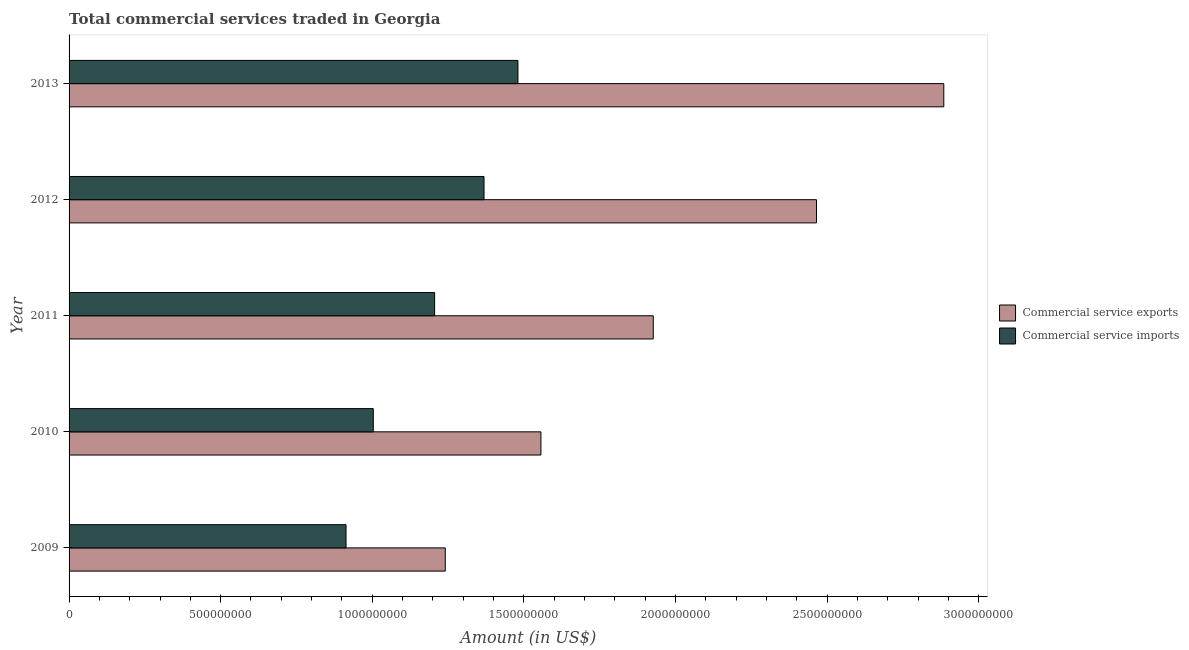How many different coloured bars are there?
Provide a short and direct response. 2. How many groups of bars are there?
Your response must be concise. 5. Are the number of bars on each tick of the Y-axis equal?
Provide a short and direct response. Yes. How many bars are there on the 1st tick from the top?
Keep it short and to the point. 2. What is the label of the 5th group of bars from the top?
Offer a very short reply. 2009. What is the amount of commercial service imports in 2011?
Provide a succinct answer. 1.21e+09. Across all years, what is the maximum amount of commercial service imports?
Keep it short and to the point. 1.48e+09. Across all years, what is the minimum amount of commercial service exports?
Your response must be concise. 1.24e+09. In which year was the amount of commercial service imports maximum?
Keep it short and to the point. 2013. What is the total amount of commercial service imports in the graph?
Your answer should be compact. 5.97e+09. What is the difference between the amount of commercial service imports in 2010 and that in 2012?
Keep it short and to the point. -3.65e+08. What is the difference between the amount of commercial service imports in 2010 and the amount of commercial service exports in 2011?
Offer a terse response. -9.23e+08. What is the average amount of commercial service imports per year?
Make the answer very short. 1.19e+09. In the year 2010, what is the difference between the amount of commercial service imports and amount of commercial service exports?
Give a very brief answer. -5.53e+08. In how many years, is the amount of commercial service exports greater than 1500000000 US$?
Give a very brief answer. 4. What is the ratio of the amount of commercial service exports in 2012 to that in 2013?
Provide a succinct answer. 0.85. Is the amount of commercial service exports in 2009 less than that in 2010?
Provide a succinct answer. Yes. Is the difference between the amount of commercial service exports in 2009 and 2010 greater than the difference between the amount of commercial service imports in 2009 and 2010?
Provide a succinct answer. No. What is the difference between the highest and the second highest amount of commercial service imports?
Make the answer very short. 1.12e+08. What is the difference between the highest and the lowest amount of commercial service exports?
Your answer should be very brief. 1.64e+09. Is the sum of the amount of commercial service imports in 2011 and 2012 greater than the maximum amount of commercial service exports across all years?
Provide a succinct answer. No. What does the 2nd bar from the top in 2009 represents?
Make the answer very short. Commercial service exports. What does the 1st bar from the bottom in 2012 represents?
Provide a succinct answer. Commercial service exports. Are the values on the major ticks of X-axis written in scientific E-notation?
Provide a succinct answer. No. Does the graph contain any zero values?
Give a very brief answer. No. Does the graph contain grids?
Provide a succinct answer. No. Where does the legend appear in the graph?
Your answer should be very brief. Center right. How are the legend labels stacked?
Your response must be concise. Vertical. What is the title of the graph?
Offer a terse response. Total commercial services traded in Georgia. Does "Current US$" appear as one of the legend labels in the graph?
Offer a terse response. No. What is the label or title of the X-axis?
Ensure brevity in your answer.  Amount (in US$). What is the label or title of the Y-axis?
Offer a terse response. Year. What is the Amount (in US$) in Commercial service exports in 2009?
Provide a succinct answer. 1.24e+09. What is the Amount (in US$) in Commercial service imports in 2009?
Give a very brief answer. 9.13e+08. What is the Amount (in US$) of Commercial service exports in 2010?
Your answer should be very brief. 1.56e+09. What is the Amount (in US$) of Commercial service imports in 2010?
Give a very brief answer. 1.00e+09. What is the Amount (in US$) of Commercial service exports in 2011?
Your response must be concise. 1.93e+09. What is the Amount (in US$) in Commercial service imports in 2011?
Make the answer very short. 1.21e+09. What is the Amount (in US$) in Commercial service exports in 2012?
Offer a very short reply. 2.47e+09. What is the Amount (in US$) of Commercial service imports in 2012?
Provide a short and direct response. 1.37e+09. What is the Amount (in US$) of Commercial service exports in 2013?
Give a very brief answer. 2.89e+09. What is the Amount (in US$) in Commercial service imports in 2013?
Your answer should be compact. 1.48e+09. Across all years, what is the maximum Amount (in US$) in Commercial service exports?
Keep it short and to the point. 2.89e+09. Across all years, what is the maximum Amount (in US$) in Commercial service imports?
Provide a succinct answer. 1.48e+09. Across all years, what is the minimum Amount (in US$) in Commercial service exports?
Make the answer very short. 1.24e+09. Across all years, what is the minimum Amount (in US$) of Commercial service imports?
Your answer should be compact. 9.13e+08. What is the total Amount (in US$) in Commercial service exports in the graph?
Give a very brief answer. 1.01e+1. What is the total Amount (in US$) of Commercial service imports in the graph?
Provide a short and direct response. 5.97e+09. What is the difference between the Amount (in US$) of Commercial service exports in 2009 and that in 2010?
Your response must be concise. -3.15e+08. What is the difference between the Amount (in US$) of Commercial service imports in 2009 and that in 2010?
Ensure brevity in your answer.  -8.99e+07. What is the difference between the Amount (in US$) of Commercial service exports in 2009 and that in 2011?
Your answer should be very brief. -6.86e+08. What is the difference between the Amount (in US$) of Commercial service imports in 2009 and that in 2011?
Offer a very short reply. -2.92e+08. What is the difference between the Amount (in US$) of Commercial service exports in 2009 and that in 2012?
Your response must be concise. -1.22e+09. What is the difference between the Amount (in US$) of Commercial service imports in 2009 and that in 2012?
Make the answer very short. -4.55e+08. What is the difference between the Amount (in US$) of Commercial service exports in 2009 and that in 2013?
Give a very brief answer. -1.64e+09. What is the difference between the Amount (in US$) in Commercial service imports in 2009 and that in 2013?
Provide a succinct answer. -5.67e+08. What is the difference between the Amount (in US$) in Commercial service exports in 2010 and that in 2011?
Provide a succinct answer. -3.71e+08. What is the difference between the Amount (in US$) of Commercial service imports in 2010 and that in 2011?
Provide a succinct answer. -2.02e+08. What is the difference between the Amount (in US$) of Commercial service exports in 2010 and that in 2012?
Offer a very short reply. -9.09e+08. What is the difference between the Amount (in US$) of Commercial service imports in 2010 and that in 2012?
Provide a succinct answer. -3.65e+08. What is the difference between the Amount (in US$) of Commercial service exports in 2010 and that in 2013?
Offer a very short reply. -1.33e+09. What is the difference between the Amount (in US$) of Commercial service imports in 2010 and that in 2013?
Offer a very short reply. -4.77e+08. What is the difference between the Amount (in US$) in Commercial service exports in 2011 and that in 2012?
Make the answer very short. -5.38e+08. What is the difference between the Amount (in US$) of Commercial service imports in 2011 and that in 2012?
Make the answer very short. -1.63e+08. What is the difference between the Amount (in US$) in Commercial service exports in 2011 and that in 2013?
Ensure brevity in your answer.  -9.58e+08. What is the difference between the Amount (in US$) in Commercial service imports in 2011 and that in 2013?
Keep it short and to the point. -2.75e+08. What is the difference between the Amount (in US$) in Commercial service exports in 2012 and that in 2013?
Offer a very short reply. -4.20e+08. What is the difference between the Amount (in US$) of Commercial service imports in 2012 and that in 2013?
Your response must be concise. -1.12e+08. What is the difference between the Amount (in US$) of Commercial service exports in 2009 and the Amount (in US$) of Commercial service imports in 2010?
Provide a short and direct response. 2.37e+08. What is the difference between the Amount (in US$) of Commercial service exports in 2009 and the Amount (in US$) of Commercial service imports in 2011?
Keep it short and to the point. 3.51e+07. What is the difference between the Amount (in US$) in Commercial service exports in 2009 and the Amount (in US$) in Commercial service imports in 2012?
Your response must be concise. -1.28e+08. What is the difference between the Amount (in US$) of Commercial service exports in 2009 and the Amount (in US$) of Commercial service imports in 2013?
Your answer should be compact. -2.40e+08. What is the difference between the Amount (in US$) in Commercial service exports in 2010 and the Amount (in US$) in Commercial service imports in 2011?
Provide a short and direct response. 3.51e+08. What is the difference between the Amount (in US$) in Commercial service exports in 2010 and the Amount (in US$) in Commercial service imports in 2012?
Offer a terse response. 1.88e+08. What is the difference between the Amount (in US$) in Commercial service exports in 2010 and the Amount (in US$) in Commercial service imports in 2013?
Your response must be concise. 7.58e+07. What is the difference between the Amount (in US$) of Commercial service exports in 2011 and the Amount (in US$) of Commercial service imports in 2012?
Provide a short and direct response. 5.58e+08. What is the difference between the Amount (in US$) in Commercial service exports in 2011 and the Amount (in US$) in Commercial service imports in 2013?
Provide a succinct answer. 4.46e+08. What is the difference between the Amount (in US$) of Commercial service exports in 2012 and the Amount (in US$) of Commercial service imports in 2013?
Give a very brief answer. 9.85e+08. What is the average Amount (in US$) in Commercial service exports per year?
Provide a short and direct response. 2.01e+09. What is the average Amount (in US$) of Commercial service imports per year?
Your answer should be compact. 1.19e+09. In the year 2009, what is the difference between the Amount (in US$) of Commercial service exports and Amount (in US$) of Commercial service imports?
Offer a very short reply. 3.27e+08. In the year 2010, what is the difference between the Amount (in US$) in Commercial service exports and Amount (in US$) in Commercial service imports?
Your answer should be compact. 5.53e+08. In the year 2011, what is the difference between the Amount (in US$) in Commercial service exports and Amount (in US$) in Commercial service imports?
Offer a terse response. 7.21e+08. In the year 2012, what is the difference between the Amount (in US$) in Commercial service exports and Amount (in US$) in Commercial service imports?
Your answer should be compact. 1.10e+09. In the year 2013, what is the difference between the Amount (in US$) of Commercial service exports and Amount (in US$) of Commercial service imports?
Make the answer very short. 1.40e+09. What is the ratio of the Amount (in US$) in Commercial service exports in 2009 to that in 2010?
Keep it short and to the point. 0.8. What is the ratio of the Amount (in US$) in Commercial service imports in 2009 to that in 2010?
Your answer should be compact. 0.91. What is the ratio of the Amount (in US$) in Commercial service exports in 2009 to that in 2011?
Your answer should be compact. 0.64. What is the ratio of the Amount (in US$) in Commercial service imports in 2009 to that in 2011?
Provide a succinct answer. 0.76. What is the ratio of the Amount (in US$) in Commercial service exports in 2009 to that in 2012?
Give a very brief answer. 0.5. What is the ratio of the Amount (in US$) of Commercial service imports in 2009 to that in 2012?
Offer a very short reply. 0.67. What is the ratio of the Amount (in US$) of Commercial service exports in 2009 to that in 2013?
Keep it short and to the point. 0.43. What is the ratio of the Amount (in US$) of Commercial service imports in 2009 to that in 2013?
Provide a short and direct response. 0.62. What is the ratio of the Amount (in US$) in Commercial service exports in 2010 to that in 2011?
Your answer should be very brief. 0.81. What is the ratio of the Amount (in US$) in Commercial service imports in 2010 to that in 2011?
Offer a very short reply. 0.83. What is the ratio of the Amount (in US$) of Commercial service exports in 2010 to that in 2012?
Your answer should be very brief. 0.63. What is the ratio of the Amount (in US$) of Commercial service imports in 2010 to that in 2012?
Your response must be concise. 0.73. What is the ratio of the Amount (in US$) in Commercial service exports in 2010 to that in 2013?
Your answer should be compact. 0.54. What is the ratio of the Amount (in US$) of Commercial service imports in 2010 to that in 2013?
Provide a succinct answer. 0.68. What is the ratio of the Amount (in US$) of Commercial service exports in 2011 to that in 2012?
Your response must be concise. 0.78. What is the ratio of the Amount (in US$) in Commercial service imports in 2011 to that in 2012?
Give a very brief answer. 0.88. What is the ratio of the Amount (in US$) in Commercial service exports in 2011 to that in 2013?
Give a very brief answer. 0.67. What is the ratio of the Amount (in US$) of Commercial service imports in 2011 to that in 2013?
Ensure brevity in your answer.  0.81. What is the ratio of the Amount (in US$) of Commercial service exports in 2012 to that in 2013?
Give a very brief answer. 0.85. What is the ratio of the Amount (in US$) in Commercial service imports in 2012 to that in 2013?
Ensure brevity in your answer.  0.92. What is the difference between the highest and the second highest Amount (in US$) of Commercial service exports?
Give a very brief answer. 4.20e+08. What is the difference between the highest and the second highest Amount (in US$) in Commercial service imports?
Your answer should be compact. 1.12e+08. What is the difference between the highest and the lowest Amount (in US$) in Commercial service exports?
Make the answer very short. 1.64e+09. What is the difference between the highest and the lowest Amount (in US$) in Commercial service imports?
Offer a terse response. 5.67e+08. 